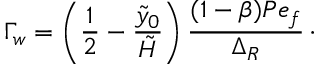Convert formula to latex. <formula><loc_0><loc_0><loc_500><loc_500>\Gamma _ { w } = \left ( \frac { 1 } { 2 } - \frac { \tilde { y } _ { 0 } } { \tilde { H } } \right ) \frac { ( 1 - \beta ) P e _ { f } } { \Delta _ { R } } \, \cdot</formula> 